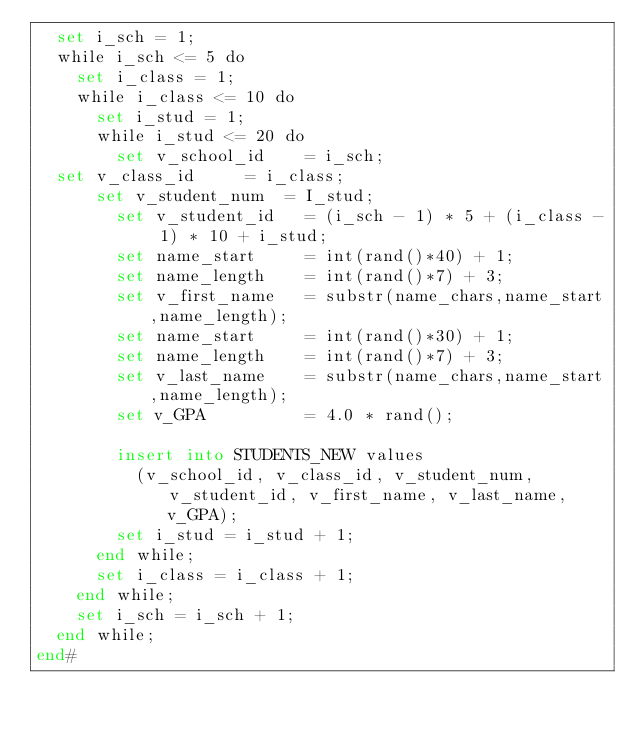Convert code to text. <code><loc_0><loc_0><loc_500><loc_500><_SQL_>  set i_sch = 1;
  while i_sch <= 5 do
    set i_class = 1;
    while i_class <= 10 do
      set i_stud = 1;
      while i_stud <= 20 do
        set v_school_id    = i_sch;
	set v_class_id     = i_class;
    	set v_student_num  = I_stud;
        set v_student_id   = (i_sch - 1) * 5 + (i_class - 1) * 10 + i_stud;
        set name_start     = int(rand()*40) + 1;
        set name_length    = int(rand()*7) + 3;
        set v_first_name   = substr(name_chars,name_start,name_length);
        set name_start     = int(rand()*30) + 1;
        set name_length    = int(rand()*7) + 3;
        set v_last_name    = substr(name_chars,name_start,name_length);
        set v_GPA          = 4.0 * rand();

        insert into STUDENTS_NEW values
          (v_school_id, v_class_id, v_student_num, v_student_id, v_first_name, v_last_name, v_GPA);
        set i_stud = i_stud + 1;
      end while;
      set i_class = i_class + 1;      
    end while;
    set i_sch = i_sch + 1;
  end while;
end#</code> 